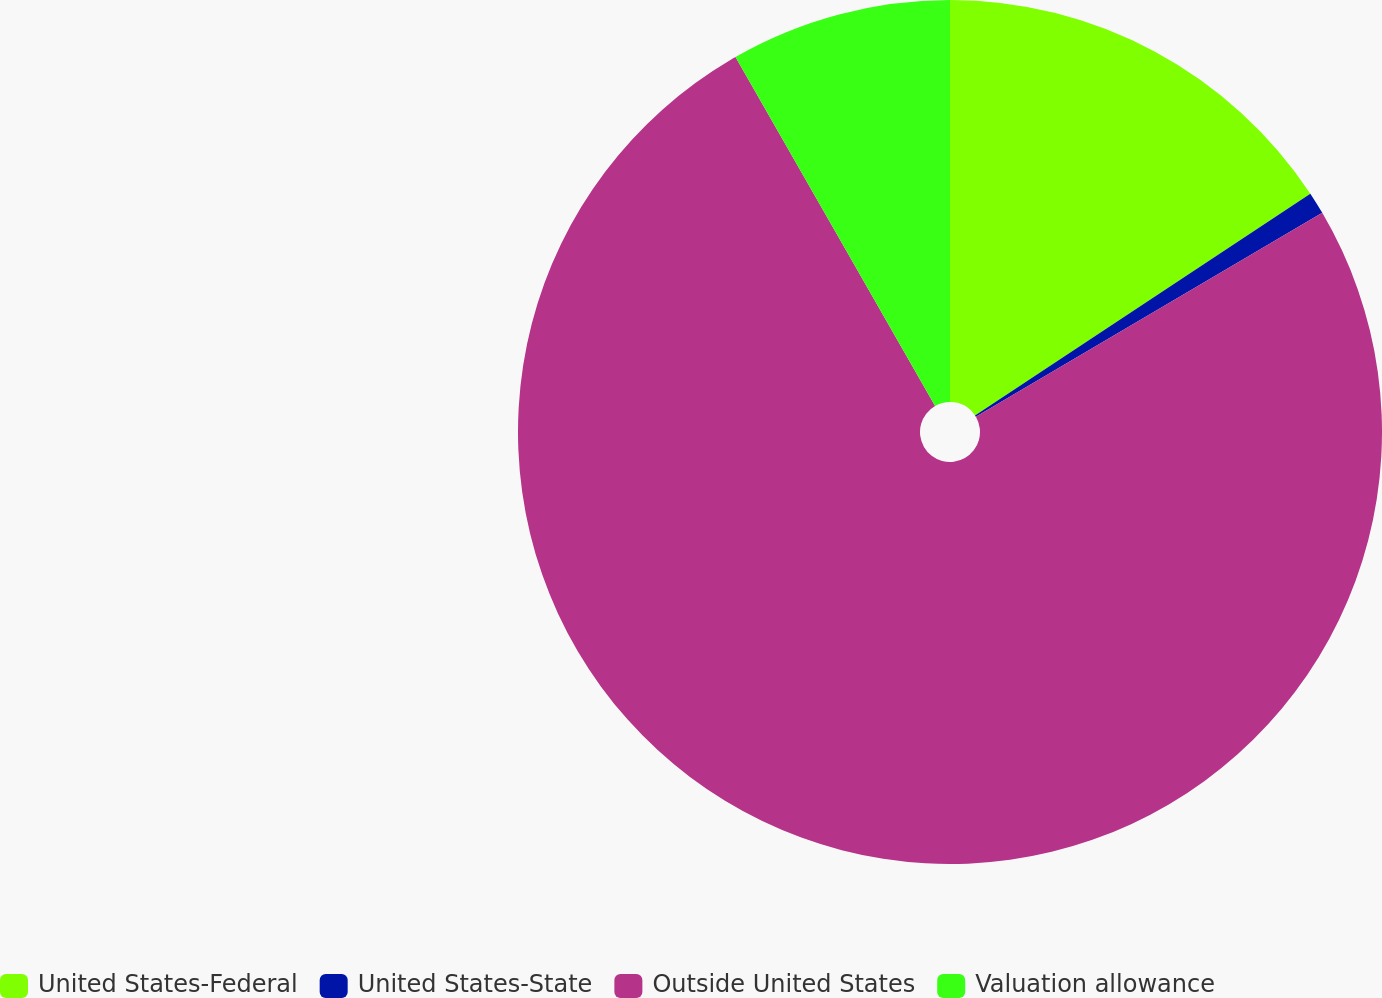Convert chart to OTSL. <chart><loc_0><loc_0><loc_500><loc_500><pie_chart><fcel>United States-Federal<fcel>United States-State<fcel>Outside United States<fcel>Valuation allowance<nl><fcel>15.7%<fcel>0.83%<fcel>75.2%<fcel>8.27%<nl></chart> 